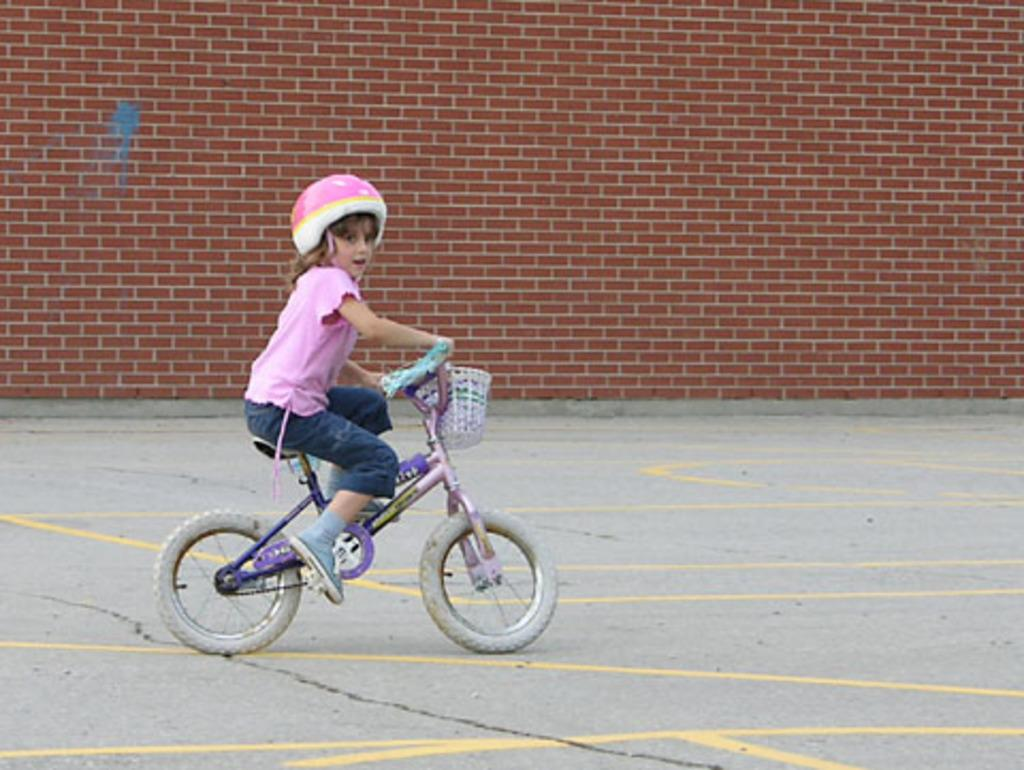Who is the main subject in the image? There is a girl in the image. What is the girl wearing on her head? The girl is wearing a helmet. What is the girl sitting on in the image? The girl is sitting on a bicycle. Where is the bicycle located? The bicycle is on a path. What can be seen in the background of the image? There is a brick wall in the background of the image. What type of yoke is the girl holding in the image? There is no yoke present in the image; the girl is wearing a helmet and sitting on a bicycle. 